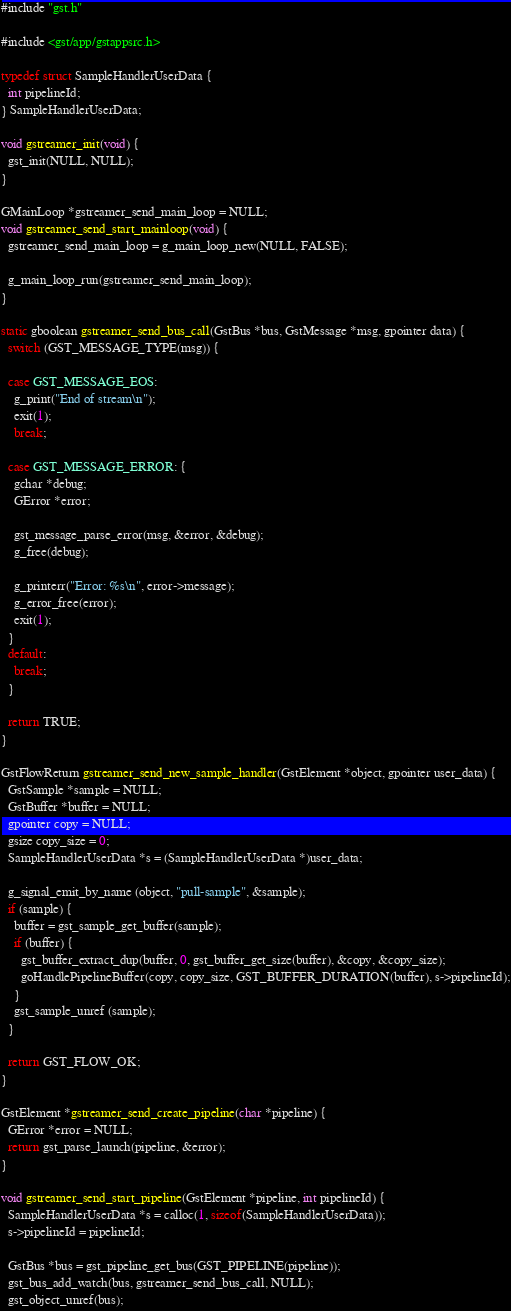Convert code to text. <code><loc_0><loc_0><loc_500><loc_500><_C_>#include "gst.h"

#include <gst/app/gstappsrc.h>

typedef struct SampleHandlerUserData {
  int pipelineId;
} SampleHandlerUserData;

void gstreamer_init(void) {
  gst_init(NULL, NULL);
}

GMainLoop *gstreamer_send_main_loop = NULL;
void gstreamer_send_start_mainloop(void) {
  gstreamer_send_main_loop = g_main_loop_new(NULL, FALSE);

  g_main_loop_run(gstreamer_send_main_loop);
}

static gboolean gstreamer_send_bus_call(GstBus *bus, GstMessage *msg, gpointer data) {
  switch (GST_MESSAGE_TYPE(msg)) {

  case GST_MESSAGE_EOS:
    g_print("End of stream\n");
    exit(1);
    break;

  case GST_MESSAGE_ERROR: {
    gchar *debug;
    GError *error;

    gst_message_parse_error(msg, &error, &debug);
    g_free(debug);

    g_printerr("Error: %s\n", error->message);
    g_error_free(error);
    exit(1);
  }
  default:
    break;
  }

  return TRUE;
}

GstFlowReturn gstreamer_send_new_sample_handler(GstElement *object, gpointer user_data) {
  GstSample *sample = NULL;
  GstBuffer *buffer = NULL;
  gpointer copy = NULL;
  gsize copy_size = 0;
  SampleHandlerUserData *s = (SampleHandlerUserData *)user_data;

  g_signal_emit_by_name (object, "pull-sample", &sample);
  if (sample) {
    buffer = gst_sample_get_buffer(sample);
    if (buffer) {
      gst_buffer_extract_dup(buffer, 0, gst_buffer_get_size(buffer), &copy, &copy_size);
      goHandlePipelineBuffer(copy, copy_size, GST_BUFFER_DURATION(buffer), s->pipelineId);
    }
    gst_sample_unref (sample);
  }

  return GST_FLOW_OK;
}

GstElement *gstreamer_send_create_pipeline(char *pipeline) {
  GError *error = NULL;
  return gst_parse_launch(pipeline, &error);
}

void gstreamer_send_start_pipeline(GstElement *pipeline, int pipelineId) {
  SampleHandlerUserData *s = calloc(1, sizeof(SampleHandlerUserData));
  s->pipelineId = pipelineId;

  GstBus *bus = gst_pipeline_get_bus(GST_PIPELINE(pipeline));
  gst_bus_add_watch(bus, gstreamer_send_bus_call, NULL);
  gst_object_unref(bus);
</code> 